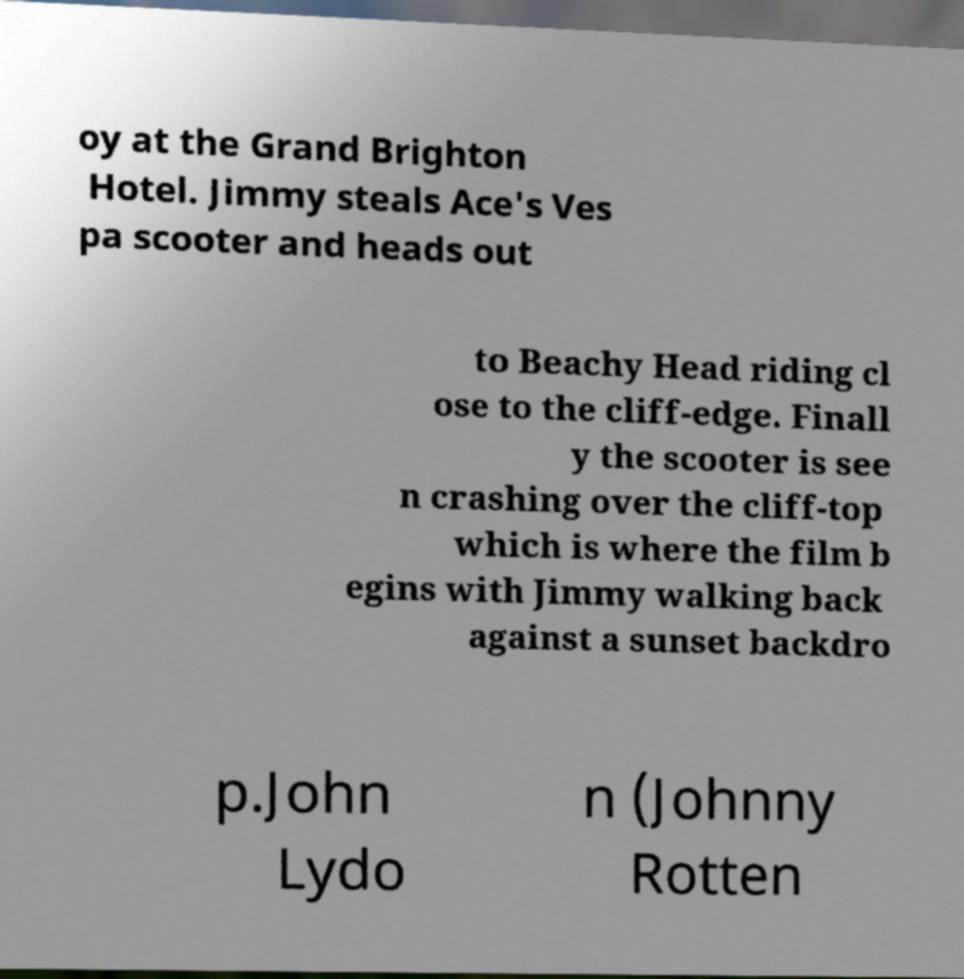There's text embedded in this image that I need extracted. Can you transcribe it verbatim? oy at the Grand Brighton Hotel. Jimmy steals Ace's Ves pa scooter and heads out to Beachy Head riding cl ose to the cliff-edge. Finall y the scooter is see n crashing over the cliff-top which is where the film b egins with Jimmy walking back against a sunset backdro p.John Lydo n (Johnny Rotten 